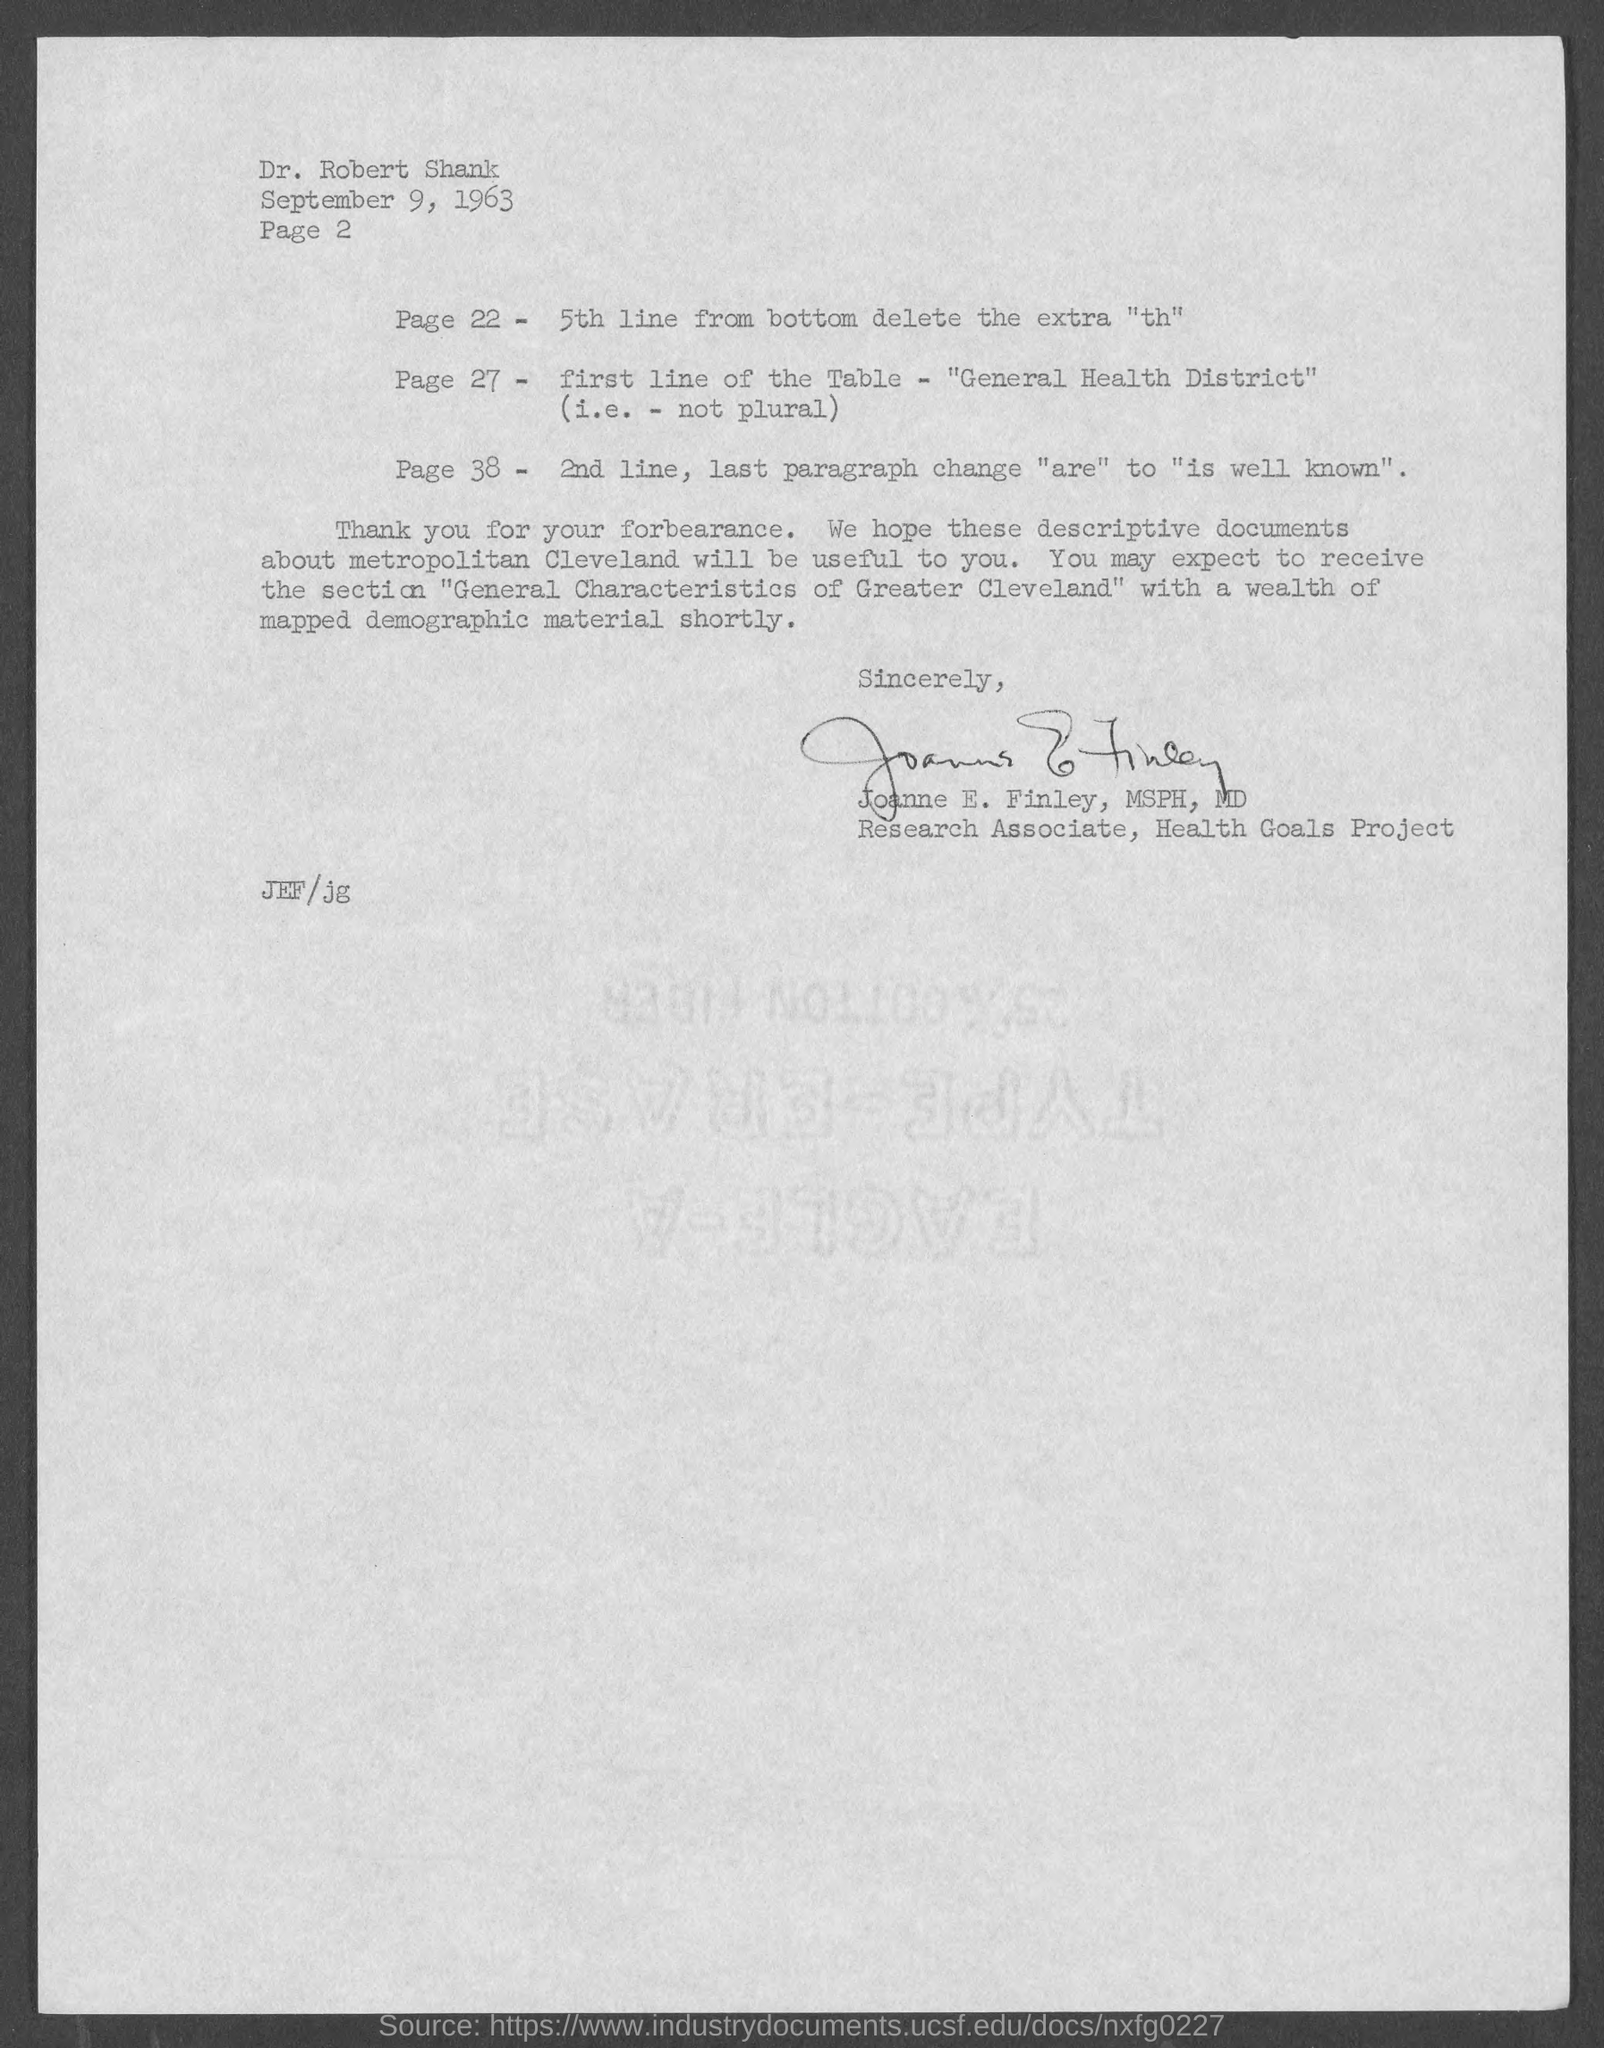What is the date mentioned in this letter?
Provide a short and direct response. September 9, 1963. Who has signed this letter?
Give a very brief answer. Joanne E. Finley, MSPH, MD. What is the designation of Joanne E. Finley, MSPH, MD?
Ensure brevity in your answer.  Research Associate, Health Goals Project. Who is the addressee of this letter?
Keep it short and to the point. Dr. Robert Shank. 